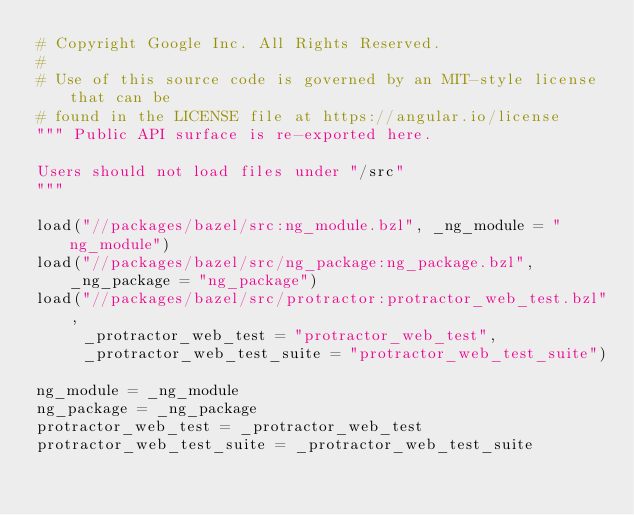Convert code to text. <code><loc_0><loc_0><loc_500><loc_500><_Python_># Copyright Google Inc. All Rights Reserved.
#
# Use of this source code is governed by an MIT-style license that can be
# found in the LICENSE file at https://angular.io/license
""" Public API surface is re-exported here.

Users should not load files under "/src"
"""

load("//packages/bazel/src:ng_module.bzl", _ng_module = "ng_module")
load("//packages/bazel/src/ng_package:ng_package.bzl", _ng_package = "ng_package")
load("//packages/bazel/src/protractor:protractor_web_test.bzl",
     _protractor_web_test = "protractor_web_test",
     _protractor_web_test_suite = "protractor_web_test_suite")

ng_module = _ng_module
ng_package = _ng_package
protractor_web_test = _protractor_web_test
protractor_web_test_suite = _protractor_web_test_suite
</code> 